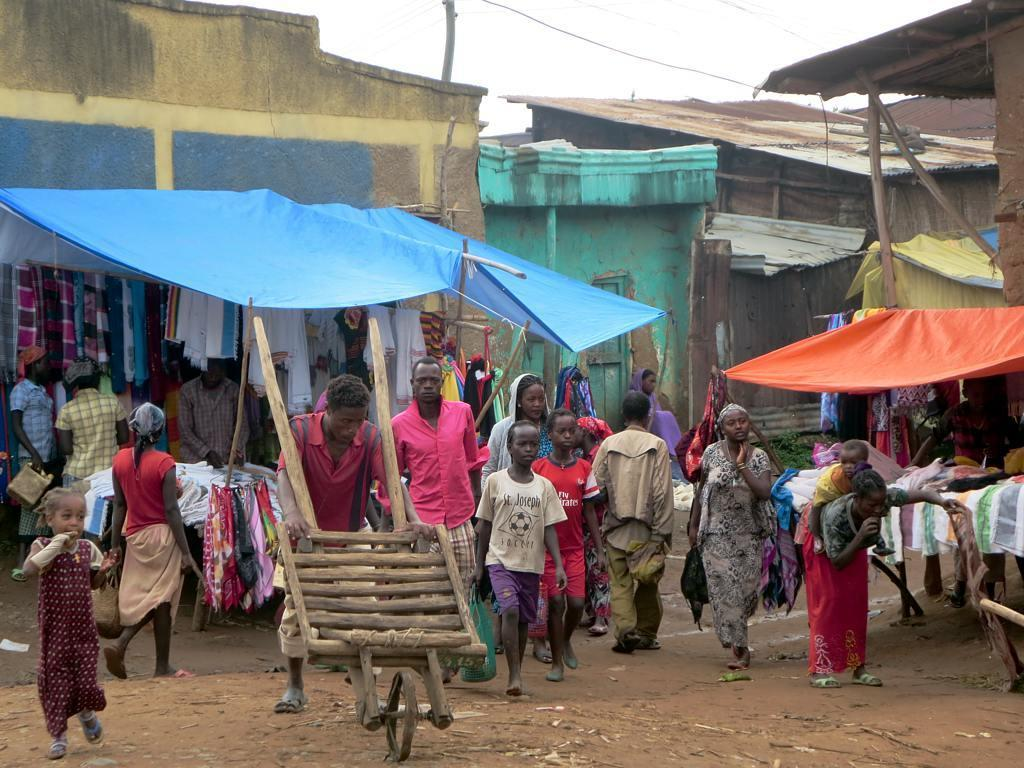How many people are in the image? There is a group of people in the image, but the exact number cannot be determined from the provided facts. What are the people in the image doing? Some people are standing, while others are walking. What can be seen in the background of the image? There are tents, houses, and cables visible in the background of the image. What type of tin is being used to collect water in the image? There is no tin present in the image, and therefore no such activity can be observed. 